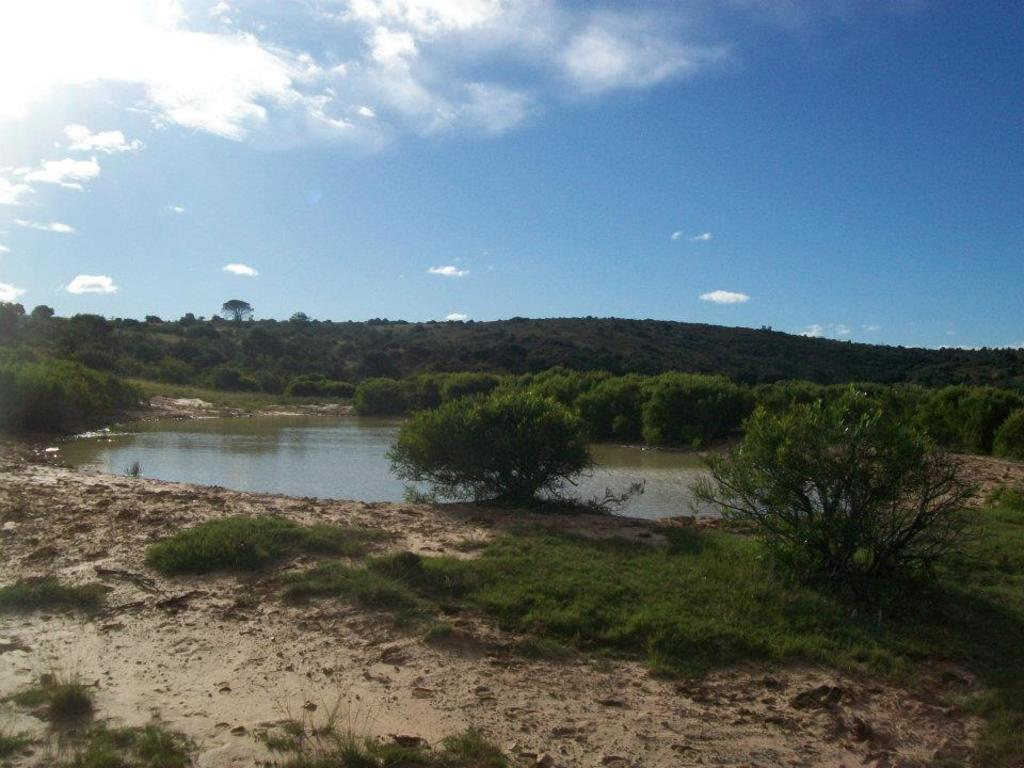What type of vegetation can be seen in the image? There are trees in the image. What geographical feature is present in the image? There is a hill in the image. What is at the bottom of the image? There is water at the bottom of the image. What covers the ground in the image? The ground is covered with grass. What can be seen in the sky at the top of the image? There are clouds in the sky at the top of the image. How many grapes are hanging from the trees in the image? There are no grapes present in the image; it features trees, a hill, water, grass, and clouds. What type of yoke is used to control the clouds in the image? There is no yoke present in the image, and the clouds are not controlled by any device or object. 